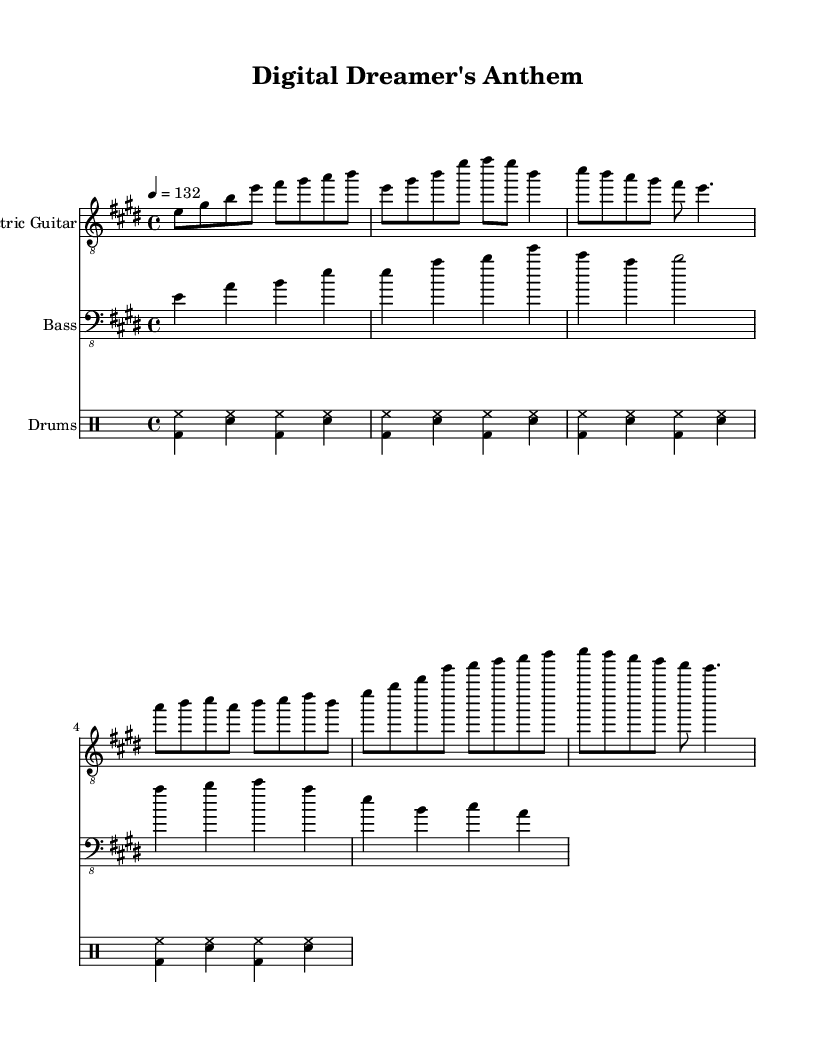What is the key signature of this music? The key signature indicated at the beginning of the score shows two sharps, which corresponds to the key of E major.
Answer: E major What is the time signature of this music? The time signature seen at the beginning of the sheet music is indicated by the "4/4" marking, meaning there are four beats in a measure and the quarter note gets one beat.
Answer: 4/4 What is the tempo marking for this piece? The tempo marking "4 = 132" indicates that there are 132 beats per minute, specifying a brisk pace for the performance.
Answer: 132 How many measures are in the verse section? By counting the measures from the marked verse section in the music, there are a total of 6 measures.
Answer: 6 What instrument plays the bass line? The bass line is indicated by the symbol for the bass guitar clef at the beginning of the corresponding staff.
Answer: Bass guitar What is the rhythmic pattern established by the drums? The drums section features a basic rock beat pattern, alternating between bass drum and snare with hi-hat, creating a consistent rhythmic drive throughout.
Answer: Basic rock beat What note group defines the beginning of the chorus? The chorus starts with the notes E, G sharp, B, E, followed by F sharp, G sharp, A, B, developing a recognizable and uplifting melodic theme.
Answer: E, G sharp, B, E 